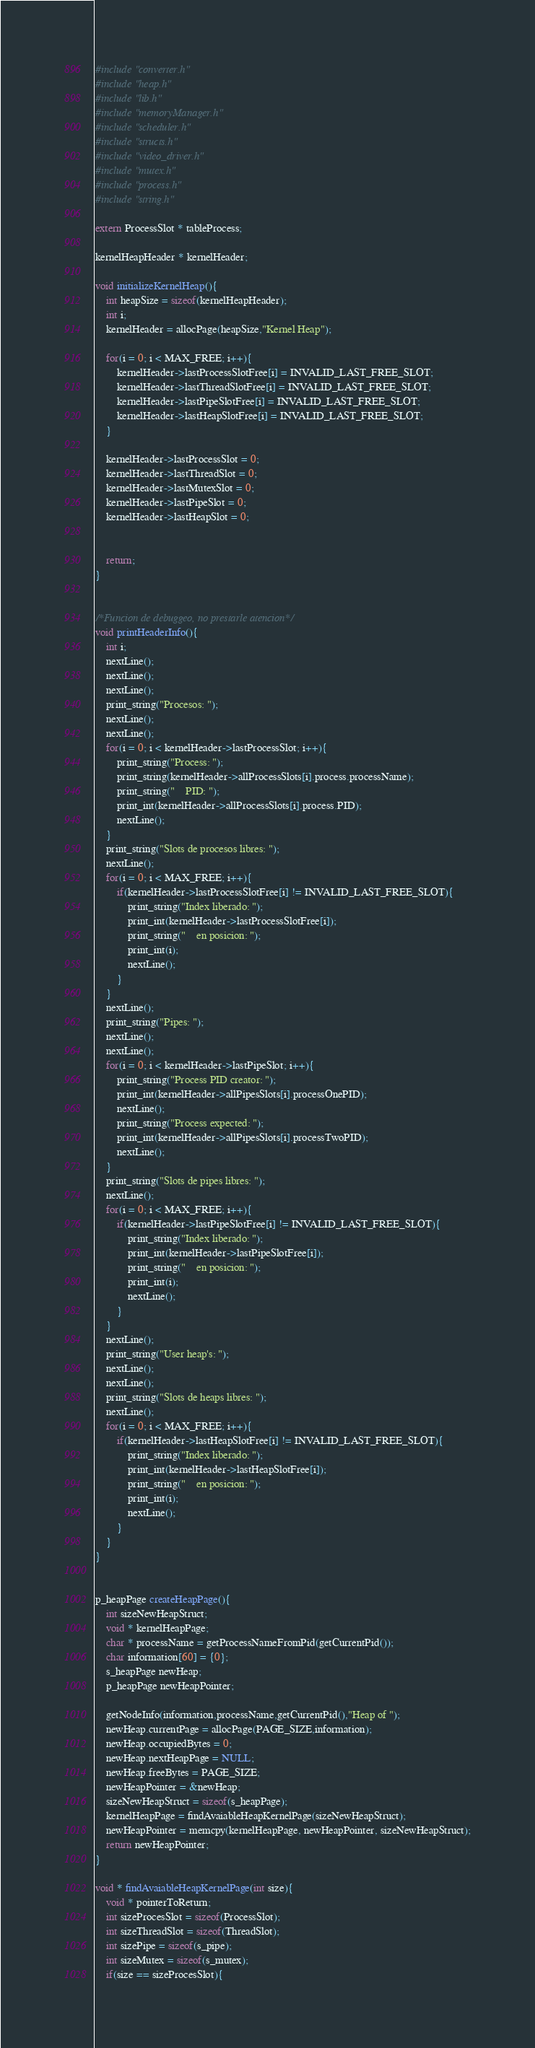Convert code to text. <code><loc_0><loc_0><loc_500><loc_500><_C_>#include "converter.h"
#include "heap.h"
#include "lib.h"
#include "memoryManager.h"
#include "scheduler.h"
#include "structs.h"
#include "video_driver.h"
#include "mutex.h"
#include "process.h"
#include "string.h"

extern ProcessSlot * tableProcess;

kernelHeapHeader * kernelHeader;

void initializeKernelHeap(){
	int heapSize = sizeof(kernelHeapHeader);
	int i;
	kernelHeader = allocPage(heapSize,"Kernel Heap");
	
	for(i = 0; i < MAX_FREE; i++){
		kernelHeader->lastProcessSlotFree[i] = INVALID_LAST_FREE_SLOT;
		kernelHeader->lastThreadSlotFree[i] = INVALID_LAST_FREE_SLOT;
		kernelHeader->lastPipeSlotFree[i] = INVALID_LAST_FREE_SLOT;
		kernelHeader->lastHeapSlotFree[i] = INVALID_LAST_FREE_SLOT;
	}

	kernelHeader->lastProcessSlot = 0;
	kernelHeader->lastThreadSlot = 0;
	kernelHeader->lastMutexSlot = 0;
	kernelHeader->lastPipeSlot = 0;
	kernelHeader->lastHeapSlot = 0;


	return;
}


/*Funcion de debuggeo, no prestarle atencion*/
void printHeaderInfo(){
	int i;
	nextLine();
	nextLine();
	nextLine();
	print_string("Procesos: ");
	nextLine();
	nextLine();
	for(i = 0; i < kernelHeader->lastProcessSlot; i++){
		print_string("Process: ");
		print_string(kernelHeader->allProcessSlots[i].process.processName);
		print_string("	PID: ");
		print_int(kernelHeader->allProcessSlots[i].process.PID);
		nextLine();
	}
	print_string("Slots de procesos libres: ");
	nextLine();
	for(i = 0; i < MAX_FREE; i++){
		if(kernelHeader->lastProcessSlotFree[i] != INVALID_LAST_FREE_SLOT){
			print_string("Index liberado: ");
			print_int(kernelHeader->lastProcessSlotFree[i]);
			print_string("	en posicion: ");
			print_int(i);
			nextLine();
		}
	}
	nextLine();
	print_string("Pipes: ");
	nextLine();
	nextLine();
	for(i = 0; i < kernelHeader->lastPipeSlot; i++){
		print_string("Process PID creator: ");
		print_int(kernelHeader->allPipesSlots[i].processOnePID);
		nextLine();
		print_string("Process expected: ");
		print_int(kernelHeader->allPipesSlots[i].processTwoPID);
		nextLine();
	}
	print_string("Slots de pipes libres: ");
	nextLine();
	for(i = 0; i < MAX_FREE; i++){
		if(kernelHeader->lastPipeSlotFree[i] != INVALID_LAST_FREE_SLOT){
			print_string("Index liberado: ");
			print_int(kernelHeader->lastPipeSlotFree[i]);
			print_string("	en posicion: ");
			print_int(i);
			nextLine();
		}
	}
	nextLine();
	print_string("User heap's: ");
	nextLine();
	nextLine();
	print_string("Slots de heaps libres: ");
	nextLine();
	for(i = 0; i < MAX_FREE; i++){
		if(kernelHeader->lastHeapSlotFree[i] != INVALID_LAST_FREE_SLOT){
			print_string("Index liberado: ");
			print_int(kernelHeader->lastHeapSlotFree[i]);
			print_string("	en posicion: ");
			print_int(i);
			nextLine();
		}
	}
}


p_heapPage createHeapPage(){
	int sizeNewHeapStruct;
	void * kernelHeapPage;
	char * processName = getProcessNameFromPid(getCurrentPid());
	char information[60] = {0};
	s_heapPage newHeap;
	p_heapPage newHeapPointer;

	getNodeInfo(information,processName,getCurrentPid(),"Heap of ");
	newHeap.currentPage = allocPage(PAGE_SIZE,information);
	newHeap.occupiedBytes = 0;
	newHeap.nextHeapPage = NULL;
	newHeap.freeBytes = PAGE_SIZE;
	newHeapPointer = &newHeap;
	sizeNewHeapStruct = sizeof(s_heapPage);
	kernelHeapPage = findAvaiableHeapKernelPage(sizeNewHeapStruct);
	newHeapPointer = memcpy(kernelHeapPage, newHeapPointer, sizeNewHeapStruct);
	return newHeapPointer;
}

void * findAvaiableHeapKernelPage(int size){
	void * pointerToReturn;
	int sizeProcesSlot = sizeof(ProcessSlot);
	int sizeThreadSlot = sizeof(ThreadSlot);
	int sizePipe = sizeof(s_pipe);
	int sizeMutex = sizeof(s_mutex);
	if(size == sizeProcesSlot){</code> 